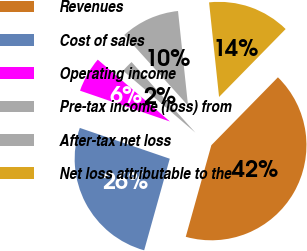Convert chart to OTSL. <chart><loc_0><loc_0><loc_500><loc_500><pie_chart><fcel>Revenues<fcel>Cost of sales<fcel>Operating income<fcel>Pre-tax income (loss) from<fcel>After-tax net loss<fcel>Net loss attributable to the<nl><fcel>42.0%<fcel>25.92%<fcel>6.02%<fcel>2.03%<fcel>10.02%<fcel>14.02%<nl></chart> 